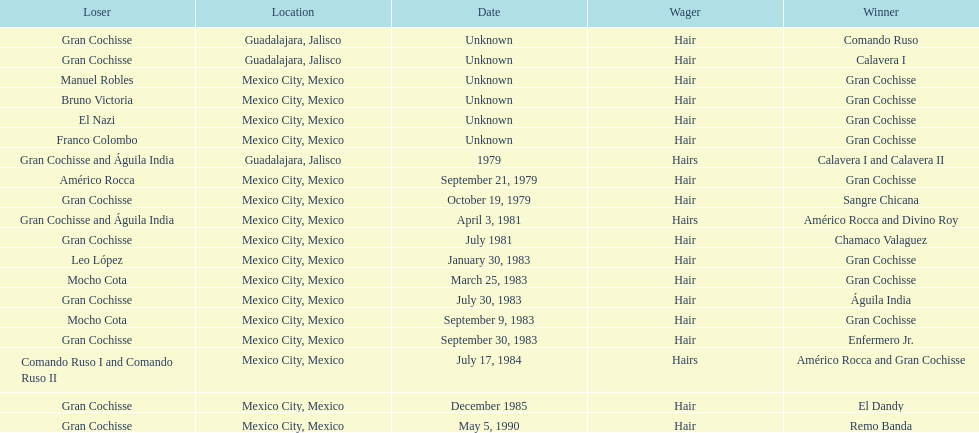When was gran chochisse first match that had a full date on record? September 21, 1979. 